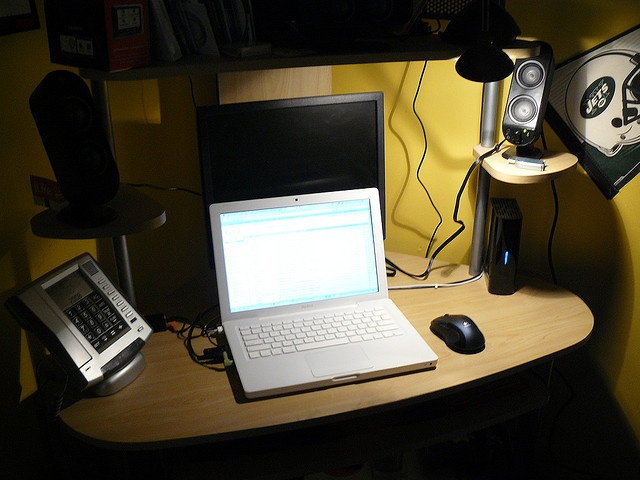Describe the objects in this image and their specific colors. I can see laptop in black, white, darkgray, and lightblue tones, tv in black, gray, and gold tones, and mouse in black, gray, and darkgray tones in this image. 